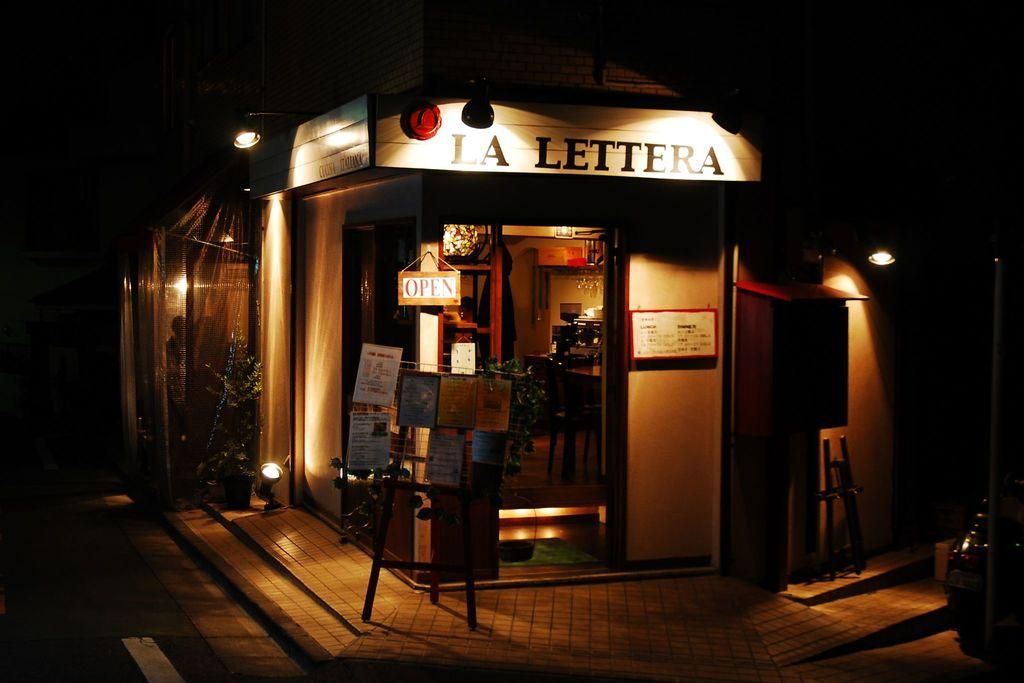<image>
Present a compact description of the photo's key features. A night time view of the exterior of the La Lettera restaurant with its menu and offers on boards outside. 